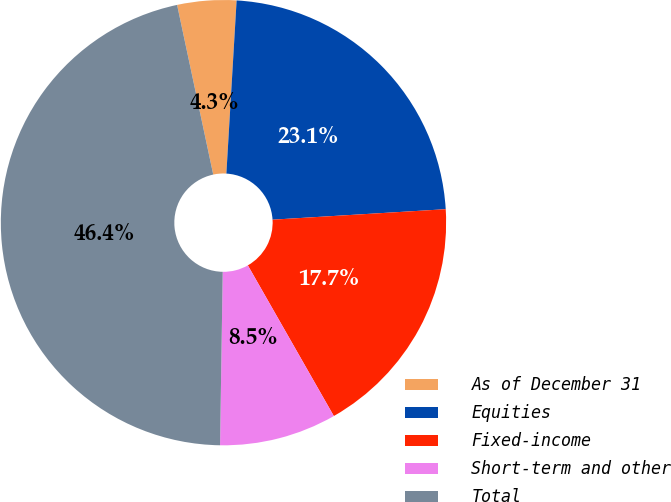Convert chart to OTSL. <chart><loc_0><loc_0><loc_500><loc_500><pie_chart><fcel>As of December 31<fcel>Equities<fcel>Fixed-income<fcel>Short-term and other<fcel>Total<nl><fcel>4.28%<fcel>23.1%<fcel>17.71%<fcel>8.5%<fcel>46.42%<nl></chart> 